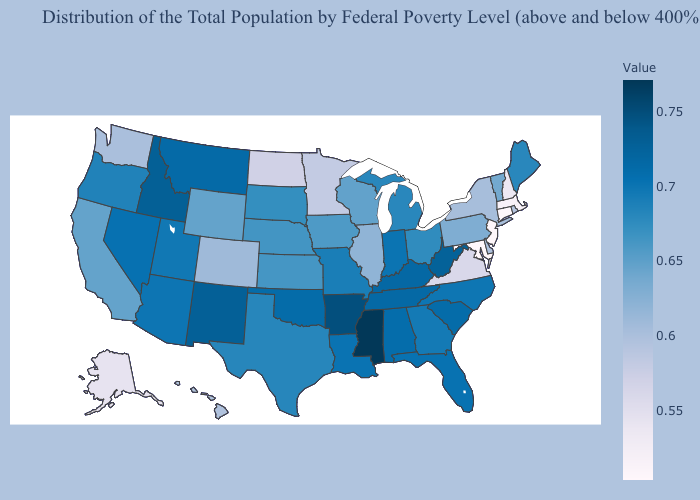Does Mississippi have the highest value in the USA?
Concise answer only. Yes. Among the states that border Utah , which have the lowest value?
Concise answer only. Colorado. Which states have the lowest value in the USA?
Short answer required. Maryland. Which states hav the highest value in the West?
Quick response, please. Idaho. Does the map have missing data?
Be succinct. No. Does Pennsylvania have a lower value than North Dakota?
Keep it brief. No. 